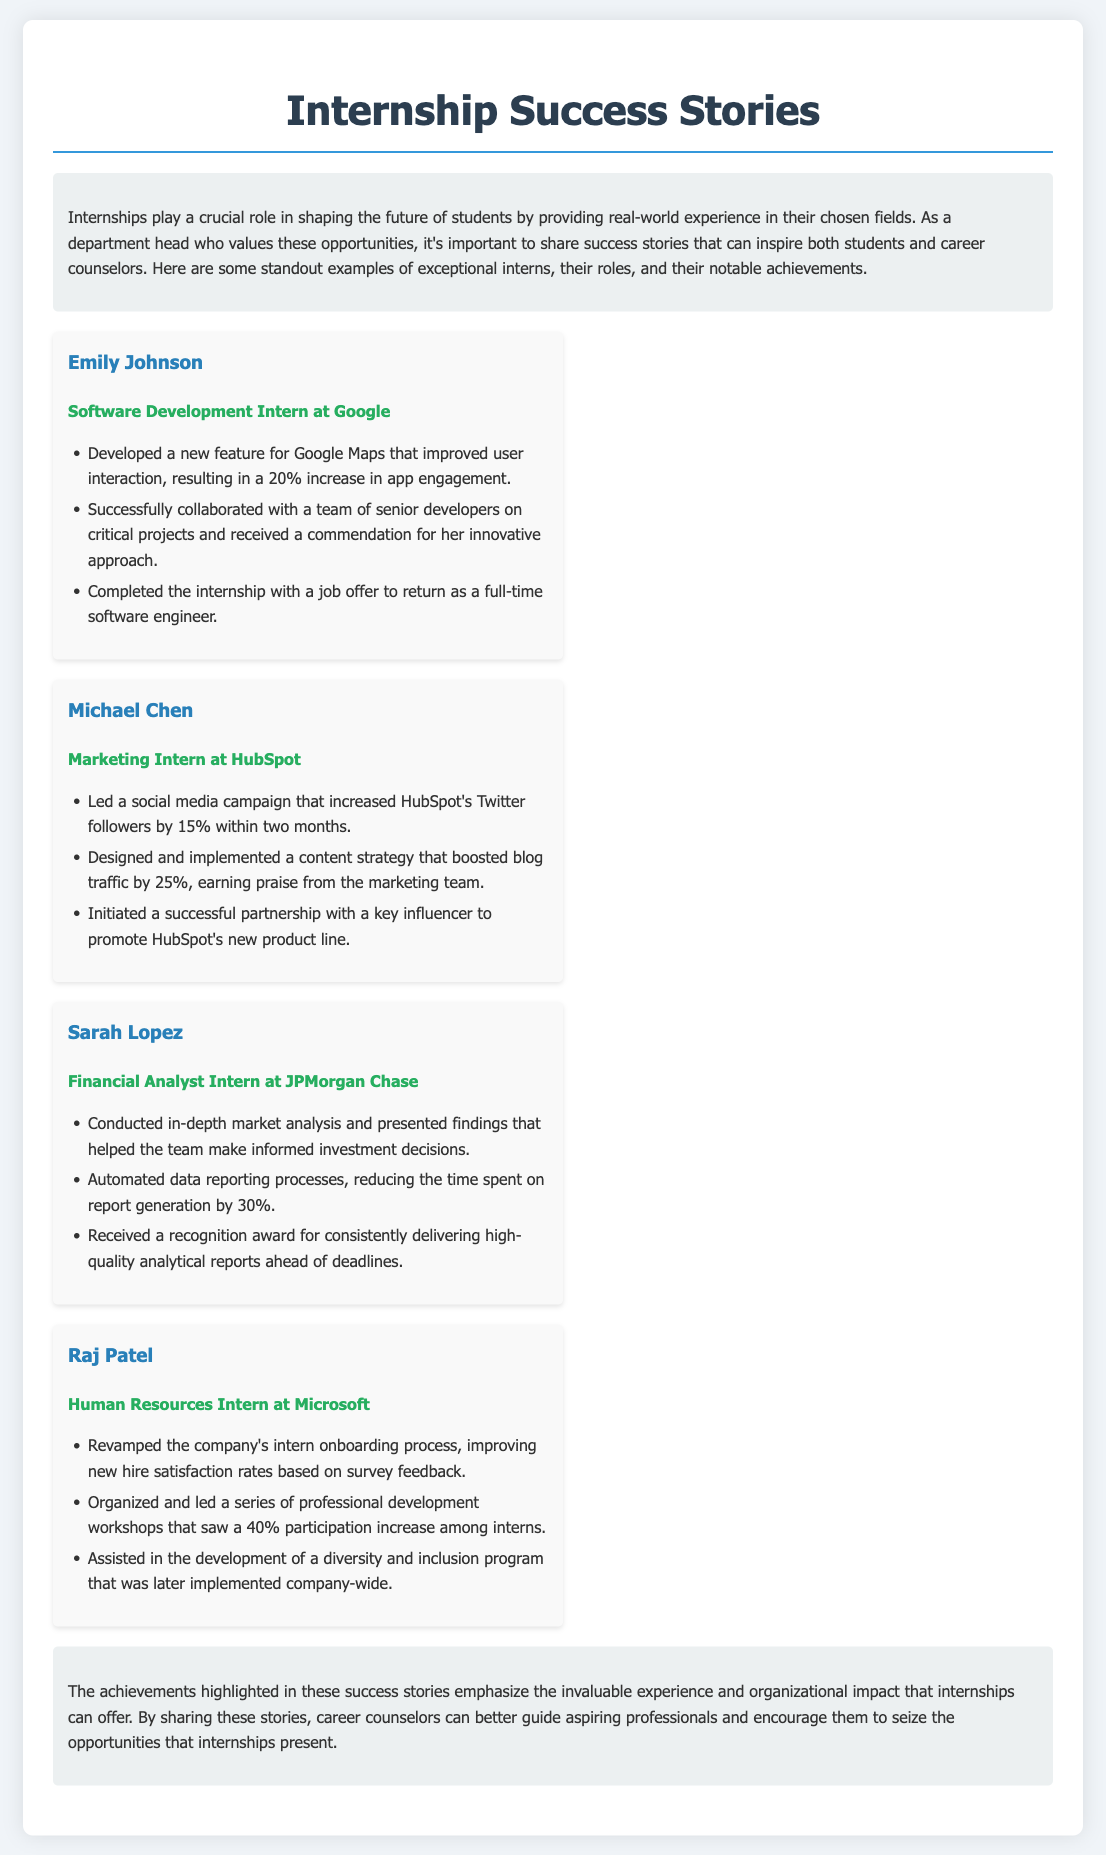What is the name of the software development intern? The document highlights Emily Johnson as the software development intern and showcases her achievements at Google.
Answer: Emily Johnson Which company did Michael Chen intern for? The document states that Michael Chen was a marketing intern at HubSpot.
Answer: HubSpot What percentage increase in Twitter followers did Michael Chen achieve? The document mentions that Michael Chen led a campaign that increased HubSpot's Twitter followers by 15%.
Answer: 15% How much did Raj Patel improve participation rates in professional development workshops? The document indicates that Raj Patel's efforts resulted in a 40% increase in participation rates among interns.
Answer: 40% What was one main achievement of Sarah Lopez? The document lists that Sarah Lopez received a recognition award for delivering high-quality analytical reports ahead of deadlines.
Answer: Recognition award Which role did Emily Johnson hold at Google? The document specifies that Emily Johnson was a Software Development Intern at Google.
Answer: Software Development Intern What notable result came from Raj Patel's work on the onboarding process? The document states that Raj Patel improved new hire satisfaction rates based on survey feedback.
Answer: New hire satisfaction rates How did internships help shape the future of students, according to the document? The introduction emphasizes that internships provide real-world experience in students' chosen fields, highlighting their crucial role.
Answer: Real-world experience What did Sarah Lopez automate during her internship? The document mentions that Sarah Lopez automated data reporting processes, which reduced report generation time.
Answer: Data reporting processes 